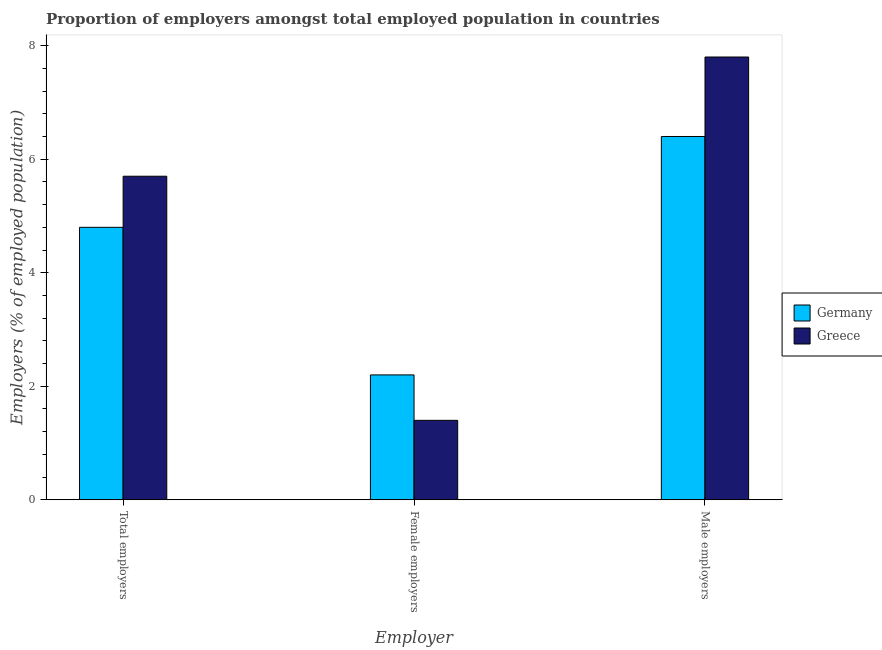How many different coloured bars are there?
Keep it short and to the point. 2. Are the number of bars per tick equal to the number of legend labels?
Provide a succinct answer. Yes. Are the number of bars on each tick of the X-axis equal?
Your answer should be compact. Yes. How many bars are there on the 2nd tick from the left?
Keep it short and to the point. 2. What is the label of the 3rd group of bars from the left?
Your answer should be compact. Male employers. What is the percentage of total employers in Greece?
Ensure brevity in your answer.  5.7. Across all countries, what is the maximum percentage of total employers?
Ensure brevity in your answer.  5.7. Across all countries, what is the minimum percentage of total employers?
Make the answer very short. 4.8. In which country was the percentage of female employers maximum?
Give a very brief answer. Germany. What is the total percentage of female employers in the graph?
Provide a succinct answer. 3.6. What is the difference between the percentage of total employers in Germany and that in Greece?
Provide a short and direct response. -0.9. What is the difference between the percentage of female employers in Germany and the percentage of total employers in Greece?
Give a very brief answer. -3.5. What is the average percentage of total employers per country?
Your answer should be compact. 5.25. What is the difference between the percentage of female employers and percentage of male employers in Germany?
Give a very brief answer. -4.2. What is the ratio of the percentage of male employers in Greece to that in Germany?
Give a very brief answer. 1.22. Is the difference between the percentage of male employers in Greece and Germany greater than the difference between the percentage of female employers in Greece and Germany?
Provide a short and direct response. Yes. What is the difference between the highest and the second highest percentage of female employers?
Your response must be concise. 0.8. What is the difference between the highest and the lowest percentage of total employers?
Keep it short and to the point. 0.9. In how many countries, is the percentage of total employers greater than the average percentage of total employers taken over all countries?
Give a very brief answer. 1. What does the 1st bar from the left in Male employers represents?
Your answer should be very brief. Germany. How many bars are there?
Offer a very short reply. 6. How many countries are there in the graph?
Offer a very short reply. 2. Are the values on the major ticks of Y-axis written in scientific E-notation?
Provide a succinct answer. No. How many legend labels are there?
Provide a succinct answer. 2. How are the legend labels stacked?
Give a very brief answer. Vertical. What is the title of the graph?
Offer a terse response. Proportion of employers amongst total employed population in countries. What is the label or title of the X-axis?
Provide a succinct answer. Employer. What is the label or title of the Y-axis?
Ensure brevity in your answer.  Employers (% of employed population). What is the Employers (% of employed population) of Germany in Total employers?
Your answer should be very brief. 4.8. What is the Employers (% of employed population) of Greece in Total employers?
Your response must be concise. 5.7. What is the Employers (% of employed population) in Germany in Female employers?
Make the answer very short. 2.2. What is the Employers (% of employed population) of Greece in Female employers?
Ensure brevity in your answer.  1.4. What is the Employers (% of employed population) of Germany in Male employers?
Keep it short and to the point. 6.4. What is the Employers (% of employed population) of Greece in Male employers?
Your response must be concise. 7.8. Across all Employer, what is the maximum Employers (% of employed population) of Germany?
Provide a succinct answer. 6.4. Across all Employer, what is the maximum Employers (% of employed population) in Greece?
Offer a terse response. 7.8. Across all Employer, what is the minimum Employers (% of employed population) of Germany?
Make the answer very short. 2.2. Across all Employer, what is the minimum Employers (% of employed population) in Greece?
Your answer should be very brief. 1.4. What is the total Employers (% of employed population) in Germany in the graph?
Your answer should be compact. 13.4. What is the difference between the Employers (% of employed population) of Germany in Total employers and that in Male employers?
Make the answer very short. -1.6. What is the difference between the Employers (% of employed population) of Greece in Total employers and that in Male employers?
Offer a very short reply. -2.1. What is the difference between the Employers (% of employed population) in Germany in Female employers and that in Male employers?
Ensure brevity in your answer.  -4.2. What is the difference between the Employers (% of employed population) in Germany in Total employers and the Employers (% of employed population) in Greece in Female employers?
Keep it short and to the point. 3.4. What is the average Employers (% of employed population) in Germany per Employer?
Your answer should be compact. 4.47. What is the average Employers (% of employed population) in Greece per Employer?
Provide a short and direct response. 4.97. What is the difference between the Employers (% of employed population) of Germany and Employers (% of employed population) of Greece in Total employers?
Provide a short and direct response. -0.9. What is the difference between the Employers (% of employed population) of Germany and Employers (% of employed population) of Greece in Female employers?
Offer a very short reply. 0.8. What is the difference between the Employers (% of employed population) in Germany and Employers (% of employed population) in Greece in Male employers?
Provide a succinct answer. -1.4. What is the ratio of the Employers (% of employed population) in Germany in Total employers to that in Female employers?
Make the answer very short. 2.18. What is the ratio of the Employers (% of employed population) of Greece in Total employers to that in Female employers?
Offer a terse response. 4.07. What is the ratio of the Employers (% of employed population) in Germany in Total employers to that in Male employers?
Ensure brevity in your answer.  0.75. What is the ratio of the Employers (% of employed population) of Greece in Total employers to that in Male employers?
Keep it short and to the point. 0.73. What is the ratio of the Employers (% of employed population) in Germany in Female employers to that in Male employers?
Your response must be concise. 0.34. What is the ratio of the Employers (% of employed population) of Greece in Female employers to that in Male employers?
Your response must be concise. 0.18. What is the difference between the highest and the second highest Employers (% of employed population) in Greece?
Your response must be concise. 2.1. What is the difference between the highest and the lowest Employers (% of employed population) in Greece?
Your answer should be very brief. 6.4. 